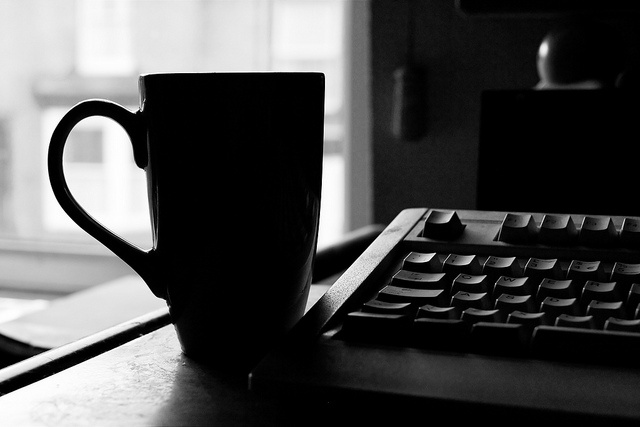Describe the objects in this image and their specific colors. I can see keyboard in lightgray, black, gray, and darkgray tones and cup in lightgray, black, white, darkgray, and gray tones in this image. 